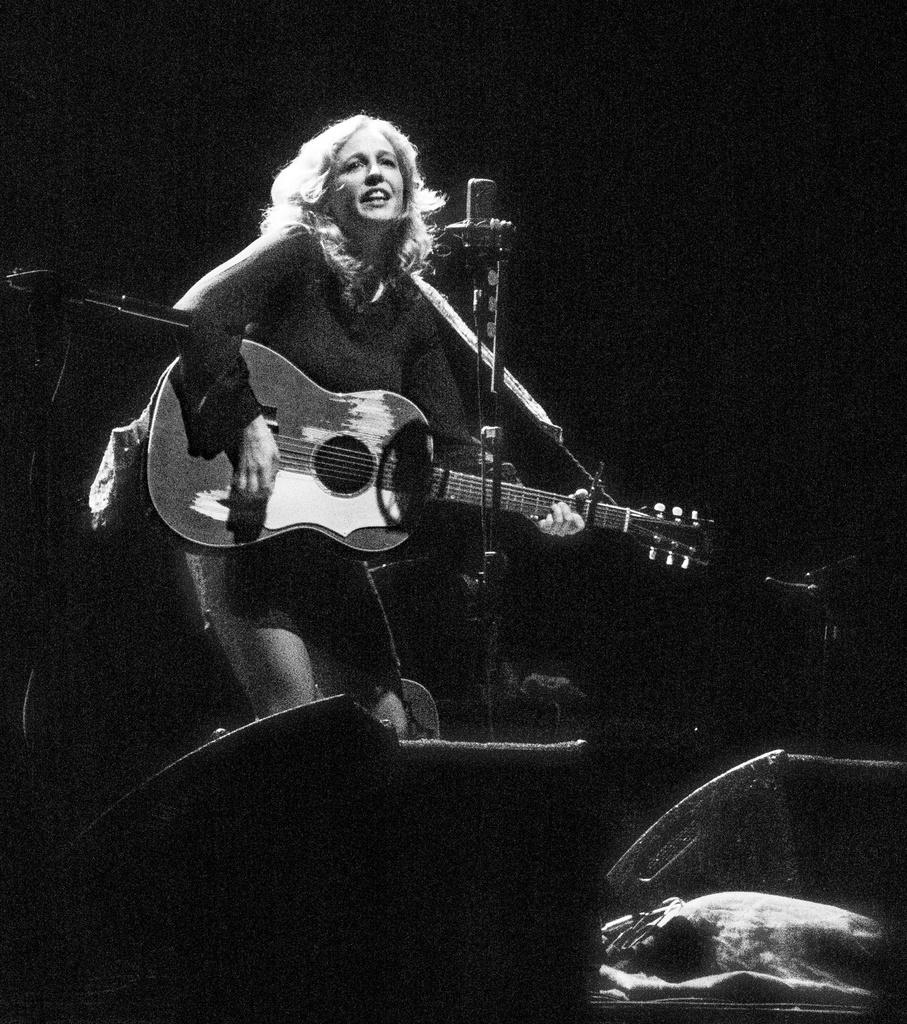Who is the main subject in the image? There is a woman in the image. What is the woman doing in the image? The woman is standing and holding a guitar. What object is in front of the woman? There is a microphone in front of the woman. What type of leaf can be seen falling from the guitar in the image? There is no leaf present in the image, and the guitar is not depicted as having any leaves. 